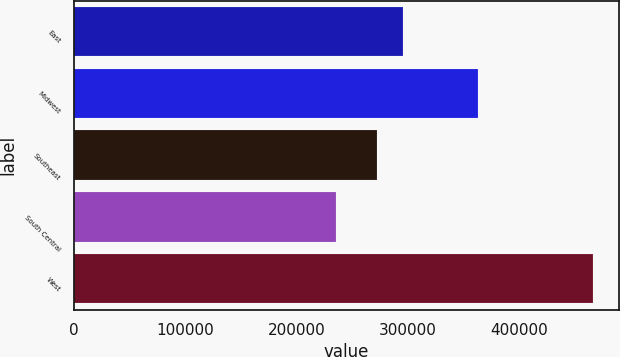Convert chart to OTSL. <chart><loc_0><loc_0><loc_500><loc_500><bar_chart><fcel>East<fcel>Midwest<fcel>Southeast<fcel>South Central<fcel>West<nl><fcel>295710<fcel>363000<fcel>272600<fcel>235800<fcel>466900<nl></chart> 